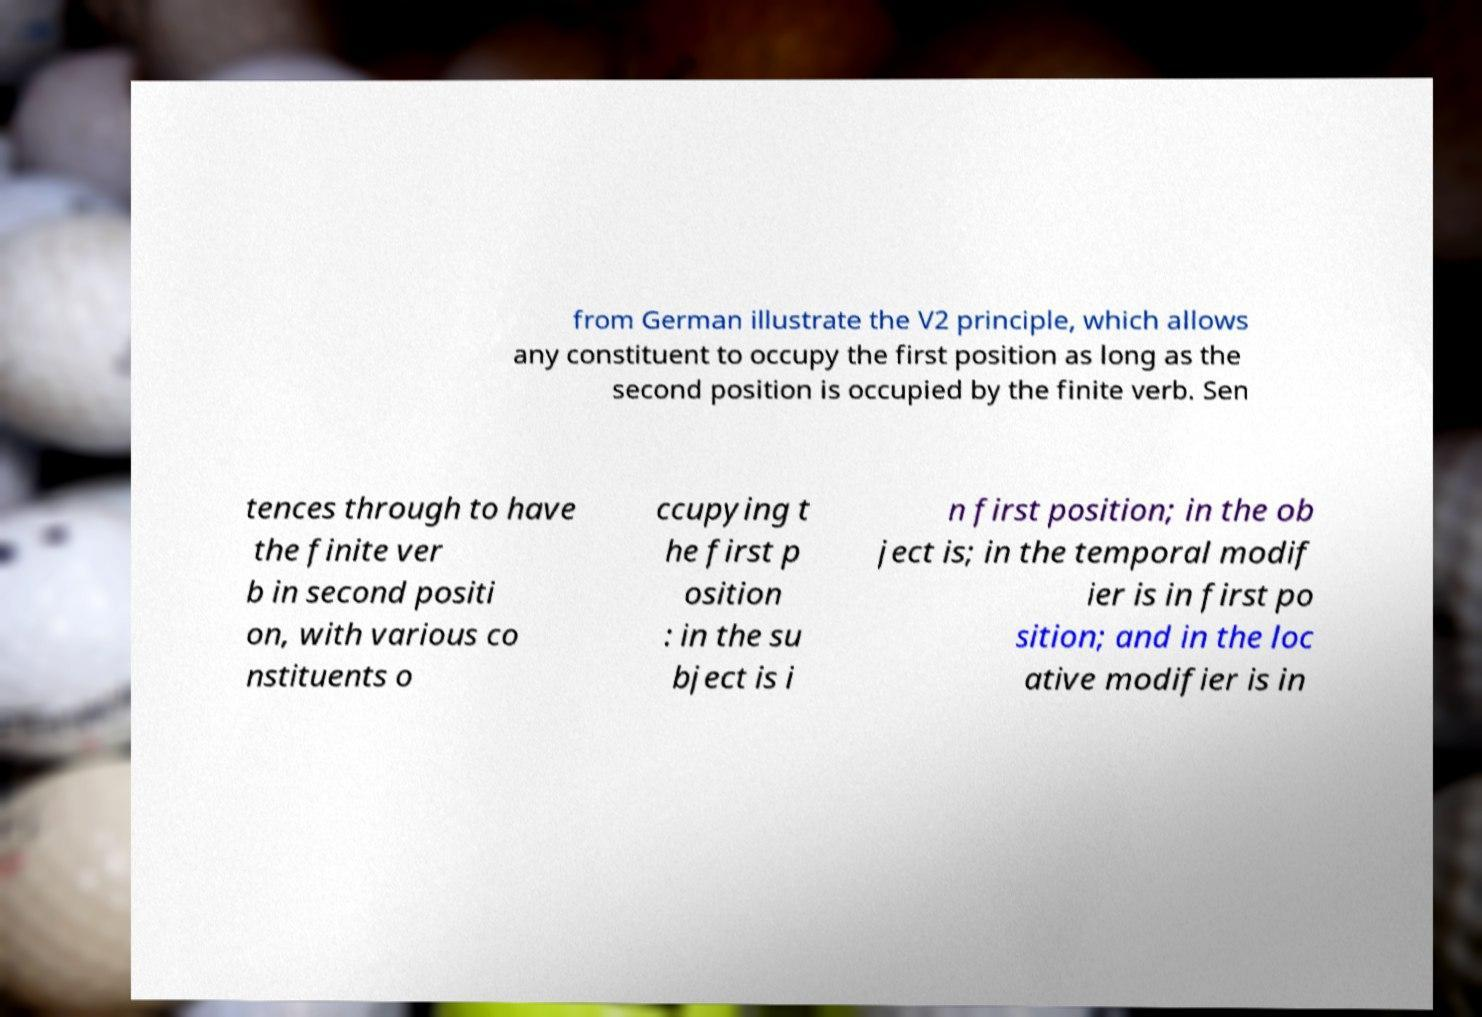Please read and relay the text visible in this image. What does it say? from German illustrate the V2 principle, which allows any constituent to occupy the first position as long as the second position is occupied by the finite verb. Sen tences through to have the finite ver b in second positi on, with various co nstituents o ccupying t he first p osition : in the su bject is i n first position; in the ob ject is; in the temporal modif ier is in first po sition; and in the loc ative modifier is in 